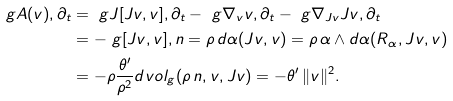<formula> <loc_0><loc_0><loc_500><loc_500>\ g { A ( v ) , \partial _ { t } } & = \ g { J [ J v , v ] , \partial _ { t } } - \ g { \nabla _ { v } v , \partial _ { t } } - \ g { \nabla _ { J v } J v , \partial _ { t } } \\ & = - \ g { [ J v , v ] , n } = \rho \, d \alpha ( J v , v ) = \rho \, \alpha \wedge d \alpha ( R _ { \alpha } , J v , v ) \\ & = - \rho \frac { \theta ^ { \prime } } { \rho ^ { 2 } } d v o l _ { g } ( \rho \, n , v , J v ) = - \theta ^ { \prime } \, \| v \| ^ { 2 } .</formula> 